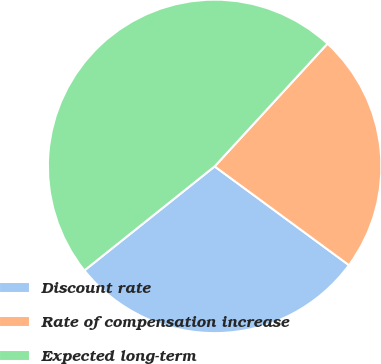<chart> <loc_0><loc_0><loc_500><loc_500><pie_chart><fcel>Discount rate<fcel>Rate of compensation increase<fcel>Expected long-term<nl><fcel>29.18%<fcel>23.26%<fcel>47.56%<nl></chart> 